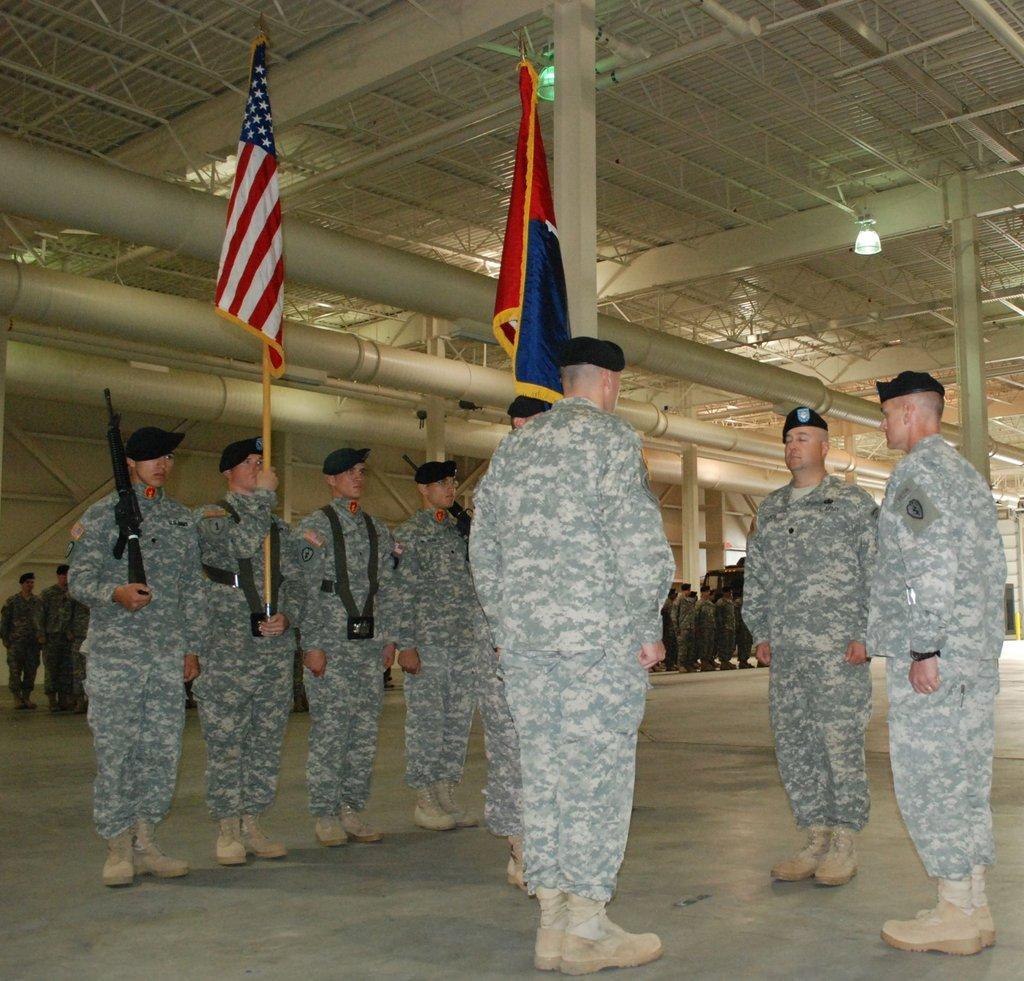Please provide a concise description of this image. In this image we can see some people wearing same uniform, among them two are holding the flags and behind there are some other people and some lights to the roof. 